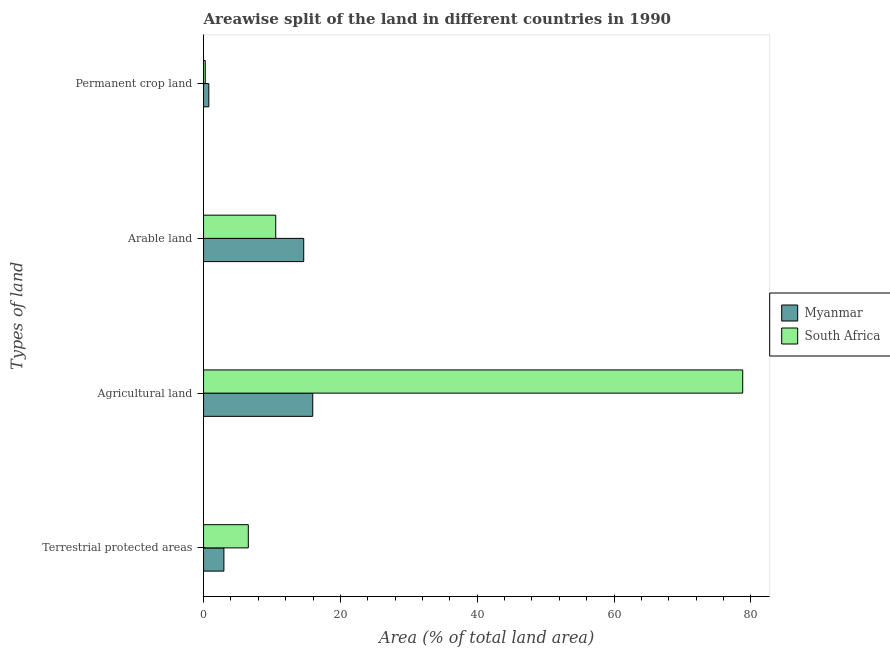How many different coloured bars are there?
Ensure brevity in your answer.  2. How many groups of bars are there?
Keep it short and to the point. 4. How many bars are there on the 3rd tick from the bottom?
Keep it short and to the point. 2. What is the label of the 1st group of bars from the top?
Your response must be concise. Permanent crop land. What is the percentage of area under permanent crop land in Myanmar?
Offer a terse response. 0.77. Across all countries, what is the maximum percentage of area under agricultural land?
Offer a very short reply. 78.81. Across all countries, what is the minimum percentage of area under permanent crop land?
Ensure brevity in your answer.  0.25. In which country was the percentage of area under permanent crop land maximum?
Provide a short and direct response. Myanmar. In which country was the percentage of area under arable land minimum?
Your answer should be very brief. South Africa. What is the total percentage of land under terrestrial protection in the graph?
Provide a succinct answer. 9.51. What is the difference between the percentage of land under terrestrial protection in Myanmar and that in South Africa?
Your answer should be very brief. -3.57. What is the difference between the percentage of land under terrestrial protection in Myanmar and the percentage of area under agricultural land in South Africa?
Offer a terse response. -75.83. What is the average percentage of area under arable land per country?
Ensure brevity in your answer.  12.6. What is the difference between the percentage of area under permanent crop land and percentage of area under agricultural land in Myanmar?
Your response must be concise. -15.19. In how many countries, is the percentage of area under arable land greater than 8 %?
Your answer should be very brief. 2. What is the ratio of the percentage of area under agricultural land in Myanmar to that in South Africa?
Provide a succinct answer. 0.2. What is the difference between the highest and the second highest percentage of area under agricultural land?
Provide a short and direct response. 62.85. What is the difference between the highest and the lowest percentage of area under permanent crop land?
Your answer should be compact. 0.52. Is the sum of the percentage of area under permanent crop land in South Africa and Myanmar greater than the maximum percentage of land under terrestrial protection across all countries?
Ensure brevity in your answer.  No. Is it the case that in every country, the sum of the percentage of area under permanent crop land and percentage of land under terrestrial protection is greater than the sum of percentage of area under agricultural land and percentage of area under arable land?
Your response must be concise. No. What does the 2nd bar from the top in Arable land represents?
Provide a succinct answer. Myanmar. What does the 1st bar from the bottom in Terrestrial protected areas represents?
Provide a succinct answer. Myanmar. Is it the case that in every country, the sum of the percentage of land under terrestrial protection and percentage of area under agricultural land is greater than the percentage of area under arable land?
Give a very brief answer. Yes. How many bars are there?
Provide a short and direct response. 8. Are the values on the major ticks of X-axis written in scientific E-notation?
Provide a short and direct response. No. Does the graph contain any zero values?
Your response must be concise. No. Does the graph contain grids?
Ensure brevity in your answer.  No. How many legend labels are there?
Offer a terse response. 2. How are the legend labels stacked?
Keep it short and to the point. Vertical. What is the title of the graph?
Ensure brevity in your answer.  Areawise split of the land in different countries in 1990. What is the label or title of the X-axis?
Offer a terse response. Area (% of total land area). What is the label or title of the Y-axis?
Give a very brief answer. Types of land. What is the Area (% of total land area) of Myanmar in Terrestrial protected areas?
Your answer should be compact. 2.97. What is the Area (% of total land area) in South Africa in Terrestrial protected areas?
Your answer should be compact. 6.54. What is the Area (% of total land area) in Myanmar in Agricultural land?
Your answer should be compact. 15.96. What is the Area (% of total land area) in South Africa in Agricultural land?
Provide a short and direct response. 78.81. What is the Area (% of total land area) of Myanmar in Arable land?
Provide a succinct answer. 14.64. What is the Area (% of total land area) in South Africa in Arable land?
Ensure brevity in your answer.  10.55. What is the Area (% of total land area) of Myanmar in Permanent crop land?
Make the answer very short. 0.77. What is the Area (% of total land area) of South Africa in Permanent crop land?
Ensure brevity in your answer.  0.25. Across all Types of land, what is the maximum Area (% of total land area) in Myanmar?
Your answer should be compact. 15.96. Across all Types of land, what is the maximum Area (% of total land area) in South Africa?
Your response must be concise. 78.81. Across all Types of land, what is the minimum Area (% of total land area) in Myanmar?
Your response must be concise. 0.77. Across all Types of land, what is the minimum Area (% of total land area) in South Africa?
Offer a terse response. 0.25. What is the total Area (% of total land area) of Myanmar in the graph?
Keep it short and to the point. 34.34. What is the total Area (% of total land area) in South Africa in the graph?
Make the answer very short. 96.15. What is the difference between the Area (% of total land area) in Myanmar in Terrestrial protected areas and that in Agricultural land?
Ensure brevity in your answer.  -12.98. What is the difference between the Area (% of total land area) in South Africa in Terrestrial protected areas and that in Agricultural land?
Provide a short and direct response. -72.27. What is the difference between the Area (% of total land area) of Myanmar in Terrestrial protected areas and that in Arable land?
Your response must be concise. -11.67. What is the difference between the Area (% of total land area) of South Africa in Terrestrial protected areas and that in Arable land?
Your response must be concise. -4.01. What is the difference between the Area (% of total land area) in Myanmar in Terrestrial protected areas and that in Permanent crop land?
Ensure brevity in your answer.  2.2. What is the difference between the Area (% of total land area) in South Africa in Terrestrial protected areas and that in Permanent crop land?
Provide a short and direct response. 6.29. What is the difference between the Area (% of total land area) in Myanmar in Agricultural land and that in Arable land?
Your response must be concise. 1.32. What is the difference between the Area (% of total land area) in South Africa in Agricultural land and that in Arable land?
Provide a short and direct response. 68.26. What is the difference between the Area (% of total land area) in Myanmar in Agricultural land and that in Permanent crop land?
Your answer should be compact. 15.19. What is the difference between the Area (% of total land area) of South Africa in Agricultural land and that in Permanent crop land?
Keep it short and to the point. 78.56. What is the difference between the Area (% of total land area) in Myanmar in Arable land and that in Permanent crop land?
Offer a terse response. 13.87. What is the difference between the Area (% of total land area) of South Africa in Arable land and that in Permanent crop land?
Make the answer very short. 10.3. What is the difference between the Area (% of total land area) in Myanmar in Terrestrial protected areas and the Area (% of total land area) in South Africa in Agricultural land?
Your response must be concise. -75.83. What is the difference between the Area (% of total land area) of Myanmar in Terrestrial protected areas and the Area (% of total land area) of South Africa in Arable land?
Your answer should be compact. -7.58. What is the difference between the Area (% of total land area) in Myanmar in Terrestrial protected areas and the Area (% of total land area) in South Africa in Permanent crop land?
Your response must be concise. 2.73. What is the difference between the Area (% of total land area) in Myanmar in Agricultural land and the Area (% of total land area) in South Africa in Arable land?
Ensure brevity in your answer.  5.4. What is the difference between the Area (% of total land area) of Myanmar in Agricultural land and the Area (% of total land area) of South Africa in Permanent crop land?
Offer a terse response. 15.71. What is the difference between the Area (% of total land area) of Myanmar in Arable land and the Area (% of total land area) of South Africa in Permanent crop land?
Your answer should be compact. 14.39. What is the average Area (% of total land area) of Myanmar per Types of land?
Provide a short and direct response. 8.58. What is the average Area (% of total land area) of South Africa per Types of land?
Your answer should be very brief. 24.04. What is the difference between the Area (% of total land area) of Myanmar and Area (% of total land area) of South Africa in Terrestrial protected areas?
Offer a very short reply. -3.57. What is the difference between the Area (% of total land area) in Myanmar and Area (% of total land area) in South Africa in Agricultural land?
Provide a succinct answer. -62.85. What is the difference between the Area (% of total land area) of Myanmar and Area (% of total land area) of South Africa in Arable land?
Make the answer very short. 4.09. What is the difference between the Area (% of total land area) of Myanmar and Area (% of total land area) of South Africa in Permanent crop land?
Provide a short and direct response. 0.52. What is the ratio of the Area (% of total land area) in Myanmar in Terrestrial protected areas to that in Agricultural land?
Give a very brief answer. 0.19. What is the ratio of the Area (% of total land area) of South Africa in Terrestrial protected areas to that in Agricultural land?
Provide a short and direct response. 0.08. What is the ratio of the Area (% of total land area) of Myanmar in Terrestrial protected areas to that in Arable land?
Offer a terse response. 0.2. What is the ratio of the Area (% of total land area) in South Africa in Terrestrial protected areas to that in Arable land?
Your response must be concise. 0.62. What is the ratio of the Area (% of total land area) of Myanmar in Terrestrial protected areas to that in Permanent crop land?
Your answer should be compact. 3.87. What is the ratio of the Area (% of total land area) of South Africa in Terrestrial protected areas to that in Permanent crop land?
Give a very brief answer. 26.45. What is the ratio of the Area (% of total land area) in Myanmar in Agricultural land to that in Arable land?
Your answer should be compact. 1.09. What is the ratio of the Area (% of total land area) of South Africa in Agricultural land to that in Arable land?
Offer a very short reply. 7.47. What is the ratio of the Area (% of total land area) of Myanmar in Agricultural land to that in Permanent crop land?
Your answer should be compact. 20.77. What is the ratio of the Area (% of total land area) of South Africa in Agricultural land to that in Permanent crop land?
Provide a succinct answer. 318.67. What is the ratio of the Area (% of total land area) in Myanmar in Arable land to that in Permanent crop land?
Offer a terse response. 19.06. What is the ratio of the Area (% of total land area) in South Africa in Arable land to that in Permanent crop land?
Your answer should be compact. 42.67. What is the difference between the highest and the second highest Area (% of total land area) of Myanmar?
Your response must be concise. 1.32. What is the difference between the highest and the second highest Area (% of total land area) in South Africa?
Make the answer very short. 68.26. What is the difference between the highest and the lowest Area (% of total land area) of Myanmar?
Offer a very short reply. 15.19. What is the difference between the highest and the lowest Area (% of total land area) in South Africa?
Give a very brief answer. 78.56. 